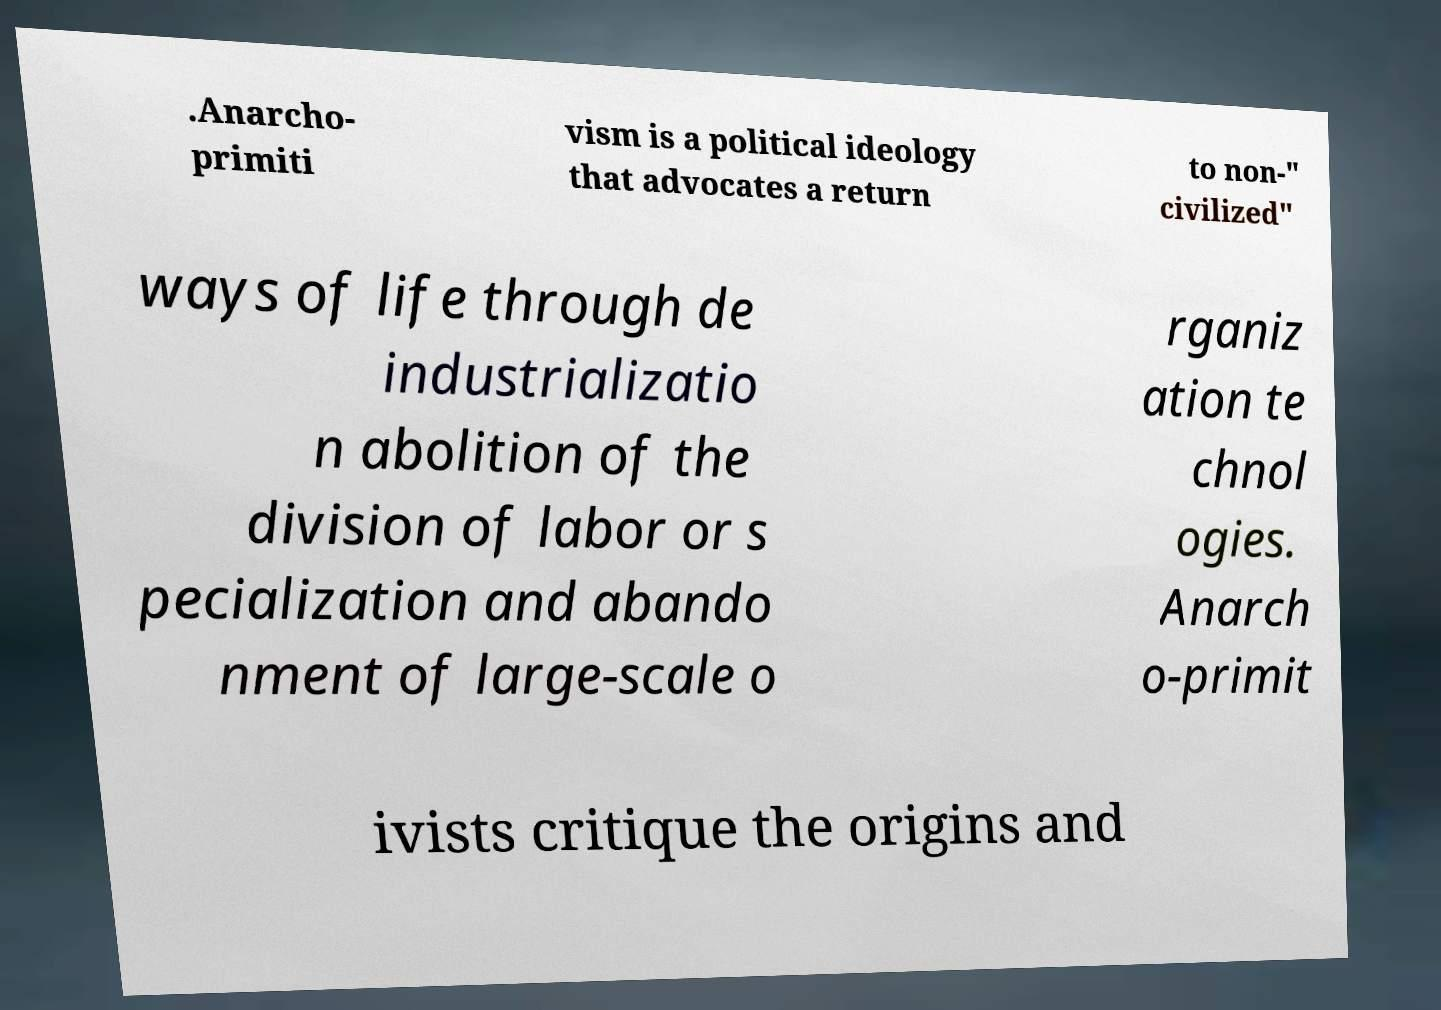What messages or text are displayed in this image? I need them in a readable, typed format. .Anarcho- primiti vism is a political ideology that advocates a return to non-" civilized" ways of life through de industrializatio n abolition of the division of labor or s pecialization and abando nment of large-scale o rganiz ation te chnol ogies. Anarch o-primit ivists critique the origins and 